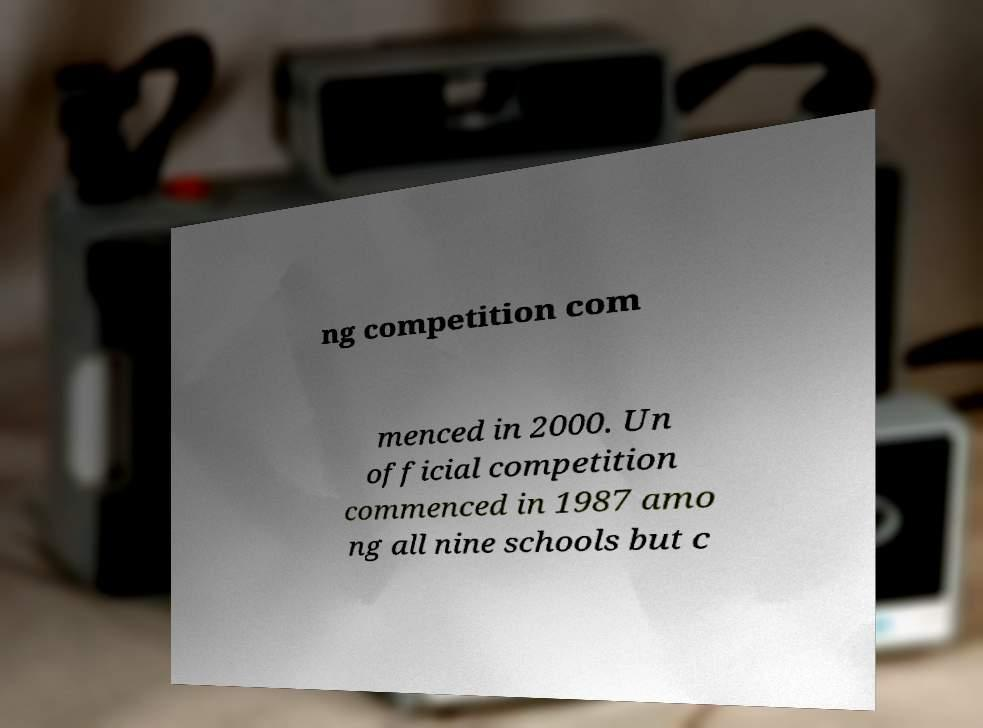Please identify and transcribe the text found in this image. ng competition com menced in 2000. Un official competition commenced in 1987 amo ng all nine schools but c 